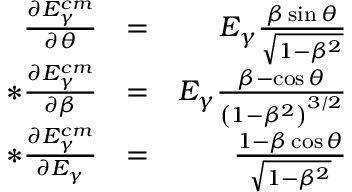<formula> <loc_0><loc_0><loc_500><loc_500>\begin{array} { r l r } { \frac { \partial E _ { \gamma } ^ { c m } } { \partial \theta } } & { = } & { E _ { \gamma } \frac { \beta \sin { \theta } } { \sqrt { 1 - \beta ^ { 2 } } } } \\ { * \frac { \partial E _ { \gamma } ^ { c m } } { \partial \beta } } & { = } & { E _ { \gamma } \frac { \beta - \cos { \theta } } { \left ( 1 - \beta ^ { 2 } \right ) ^ { 3 / 2 } } } \\ { * \frac { \partial E _ { \gamma } ^ { c m } } { \partial E _ { \gamma } } } & { = } & { \frac { 1 - \beta \cos { \theta } } { \sqrt { 1 - \beta ^ { 2 } } } } \end{array}</formula> 